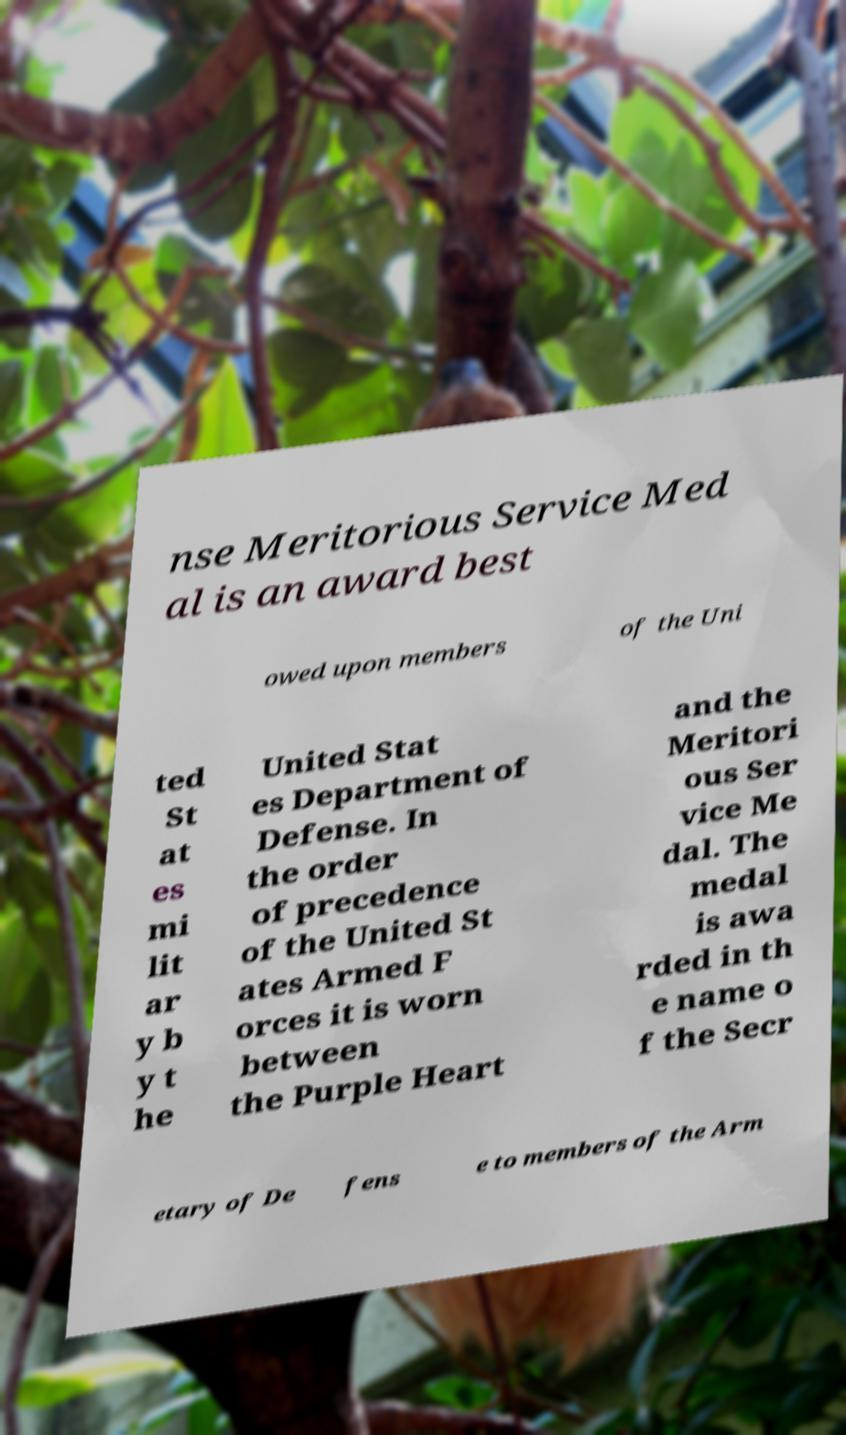I need the written content from this picture converted into text. Can you do that? nse Meritorious Service Med al is an award best owed upon members of the Uni ted St at es mi lit ar y b y t he United Stat es Department of Defense. In the order of precedence of the United St ates Armed F orces it is worn between the Purple Heart and the Meritori ous Ser vice Me dal. The medal is awa rded in th e name o f the Secr etary of De fens e to members of the Arm 